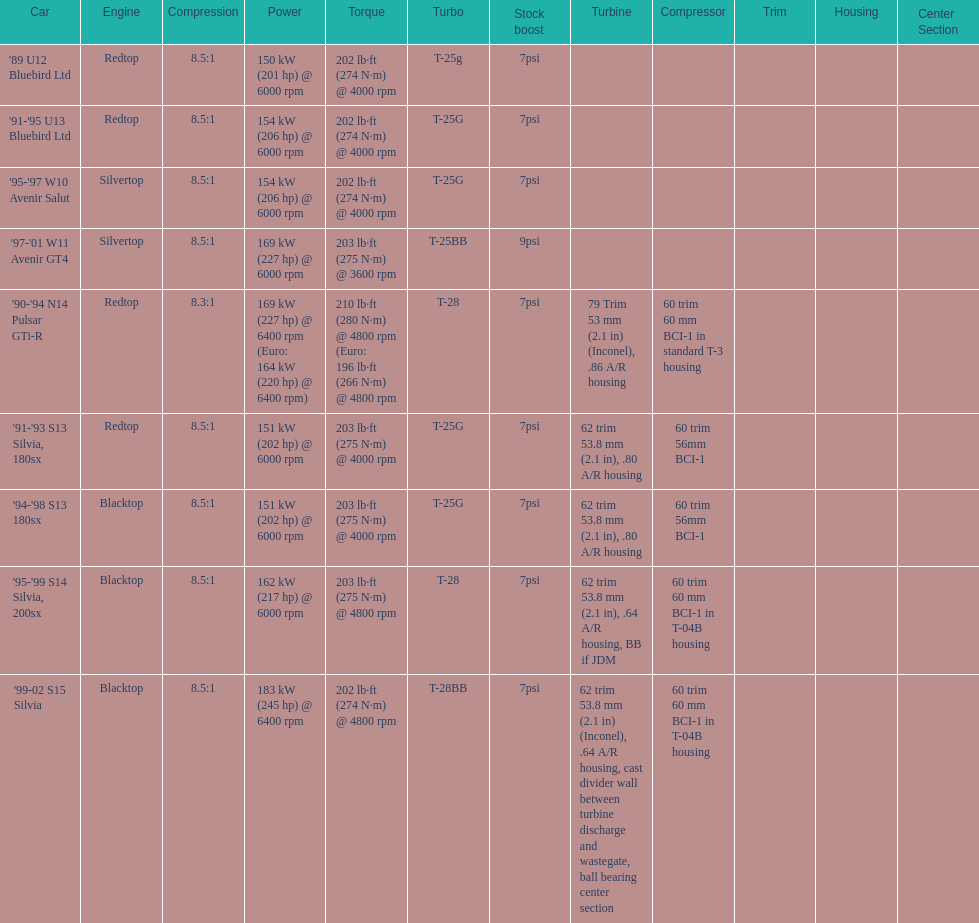Help me parse the entirety of this table. {'header': ['Car', 'Engine', 'Compression', 'Power', 'Torque', 'Turbo', 'Stock boost', 'Turbine', 'Compressor', 'Trim', 'Housing', 'Center Section'], 'rows': [["'89 U12 Bluebird Ltd", 'Redtop', '8.5:1', '150\xa0kW (201\xa0hp) @ 6000 rpm', '202\xa0lb·ft (274\xa0N·m) @ 4000 rpm', 'T-25g', '7psi', '', '', '', '', ''], ["'91-'95 U13 Bluebird Ltd", 'Redtop', '8.5:1', '154\xa0kW (206\xa0hp) @ 6000 rpm', '202\xa0lb·ft (274\xa0N·m) @ 4000 rpm', 'T-25G', '7psi', '', '', '', '', ''], ["'95-'97 W10 Avenir Salut", 'Silvertop', '8.5:1', '154\xa0kW (206\xa0hp) @ 6000 rpm', '202\xa0lb·ft (274\xa0N·m) @ 4000 rpm', 'T-25G', '7psi', '', '', '', '', ''], ["'97-'01 W11 Avenir GT4", 'Silvertop', '8.5:1', '169\xa0kW (227\xa0hp) @ 6000 rpm', '203\xa0lb·ft (275\xa0N·m) @ 3600 rpm', 'T-25BB', '9psi', '', '', '', '', ''], ["'90-'94 N14 Pulsar GTi-R", 'Redtop', '8.3:1', '169\xa0kW (227\xa0hp) @ 6400 rpm (Euro: 164\xa0kW (220\xa0hp) @ 6400 rpm)', '210\xa0lb·ft (280\xa0N·m) @ 4800 rpm (Euro: 196\xa0lb·ft (266\xa0N·m) @ 4800 rpm', 'T-28', '7psi', '79 Trim 53\xa0mm (2.1\xa0in) (Inconel), .86 A/R housing', '60 trim 60\xa0mm BCI-1 in standard T-3 housing', '', '', ''], ["'91-'93 S13 Silvia, 180sx", 'Redtop', '8.5:1', '151\xa0kW (202\xa0hp) @ 6000 rpm', '203\xa0lb·ft (275\xa0N·m) @ 4000 rpm', 'T-25G', '7psi', '62 trim 53.8\xa0mm (2.1\xa0in), .80 A/R housing', '60 trim 56mm BCI-1', '', '', ''], ["'94-'98 S13 180sx", 'Blacktop', '8.5:1', '151\xa0kW (202\xa0hp) @ 6000 rpm', '203\xa0lb·ft (275\xa0N·m) @ 4000 rpm', 'T-25G', '7psi', '62 trim 53.8\xa0mm (2.1\xa0in), .80 A/R housing', '60 trim 56mm BCI-1', '', '', ''], ["'95-'99 S14 Silvia, 200sx", 'Blacktop', '8.5:1', '162\xa0kW (217\xa0hp) @ 6000 rpm', '203\xa0lb·ft (275\xa0N·m) @ 4800 rpm', 'T-28', '7psi', '62 trim 53.8\xa0mm (2.1\xa0in), .64 A/R housing, BB if JDM', '60 trim 60\xa0mm BCI-1 in T-04B housing', '', '', ''], ["'99-02 S15 Silvia", 'Blacktop', '8.5:1', '183\xa0kW (245\xa0hp) @ 6400 rpm', '202\xa0lb·ft (274\xa0N·m) @ 4800 rpm', 'T-28BB', '7psi', '62 trim 53.8\xa0mm (2.1\xa0in) (Inconel), .64 A/R housing, cast divider wall between turbine discharge and wastegate, ball bearing center section', '60 trim 60\xa0mm BCI-1 in T-04B housing', '', '', '']]} Which engine(s) has the least amount of power? Redtop. 